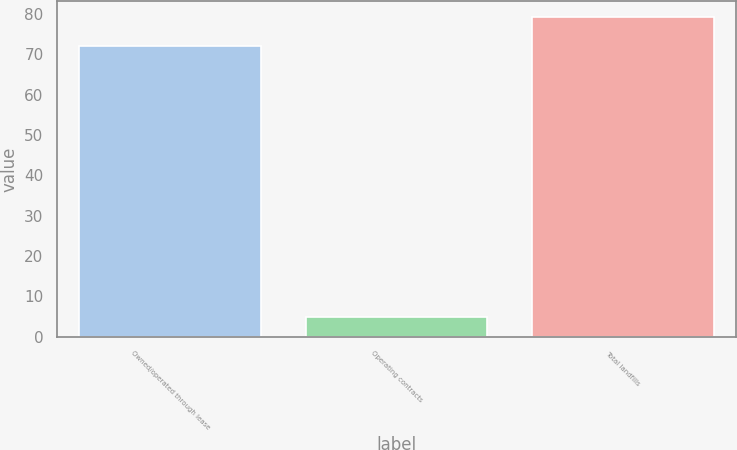Convert chart to OTSL. <chart><loc_0><loc_0><loc_500><loc_500><bar_chart><fcel>Owned/operated through lease<fcel>Operating contracts<fcel>Total landfills<nl><fcel>72<fcel>5<fcel>79.2<nl></chart> 